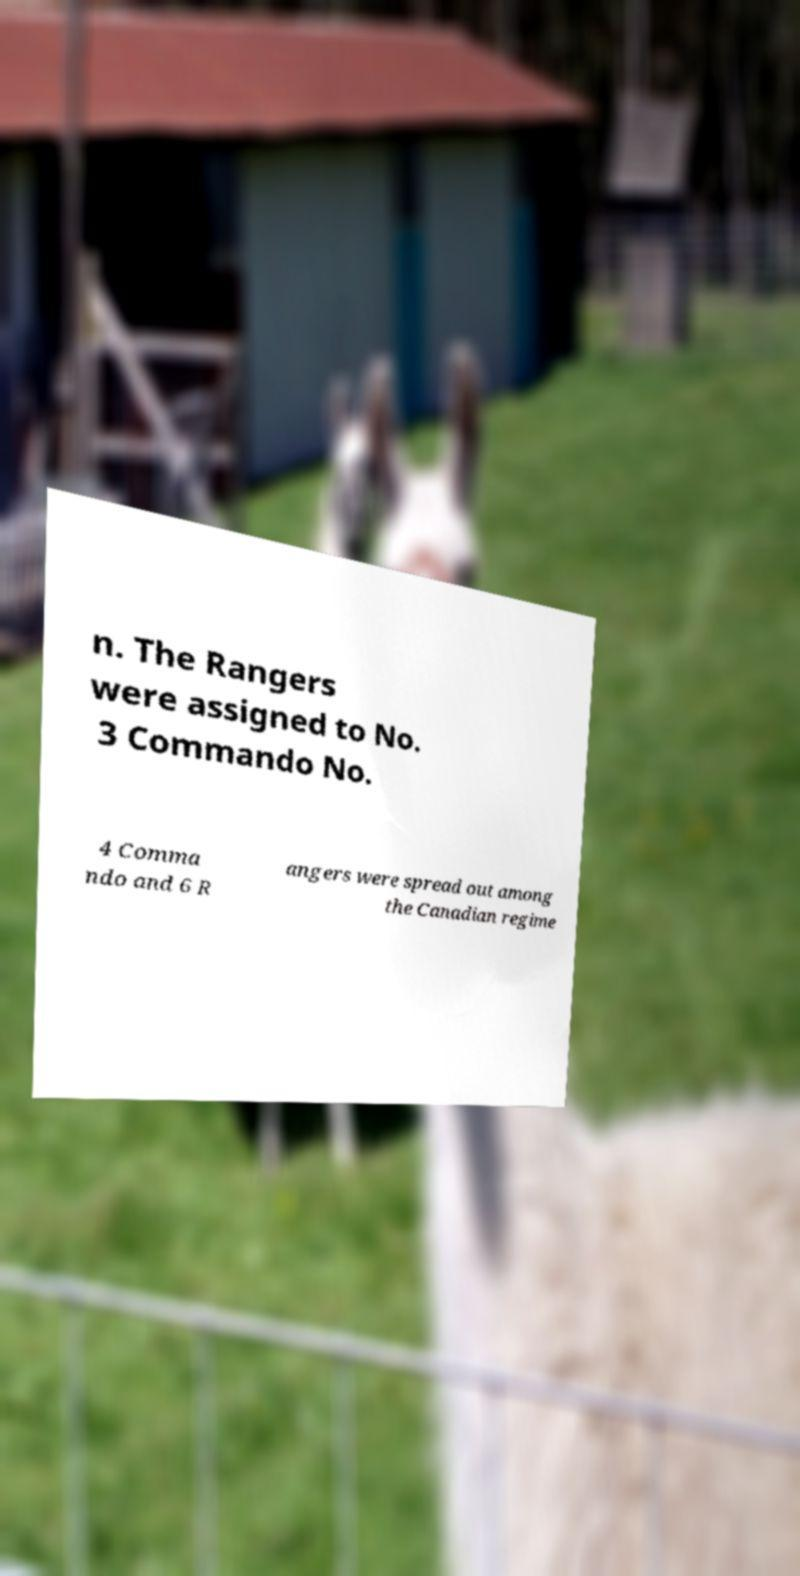For documentation purposes, I need the text within this image transcribed. Could you provide that? n. The Rangers were assigned to No. 3 Commando No. 4 Comma ndo and 6 R angers were spread out among the Canadian regime 